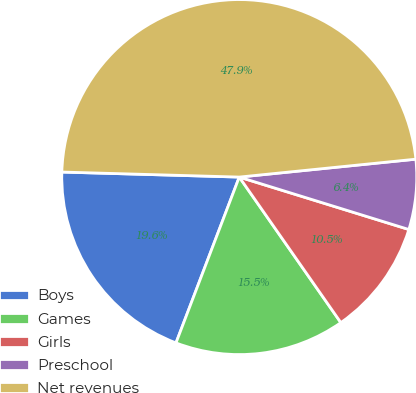<chart> <loc_0><loc_0><loc_500><loc_500><pie_chart><fcel>Boys<fcel>Games<fcel>Girls<fcel>Preschool<fcel>Net revenues<nl><fcel>19.65%<fcel>15.5%<fcel>10.53%<fcel>6.38%<fcel>47.94%<nl></chart> 